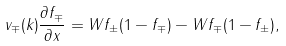<formula> <loc_0><loc_0><loc_500><loc_500>v _ { \mp } ( k ) \frac { \partial f _ { \mp } } { \partial x } = W f _ { \pm } ( 1 - f _ { \mp } ) - W f _ { \mp } ( 1 - f _ { \pm } ) ,</formula> 